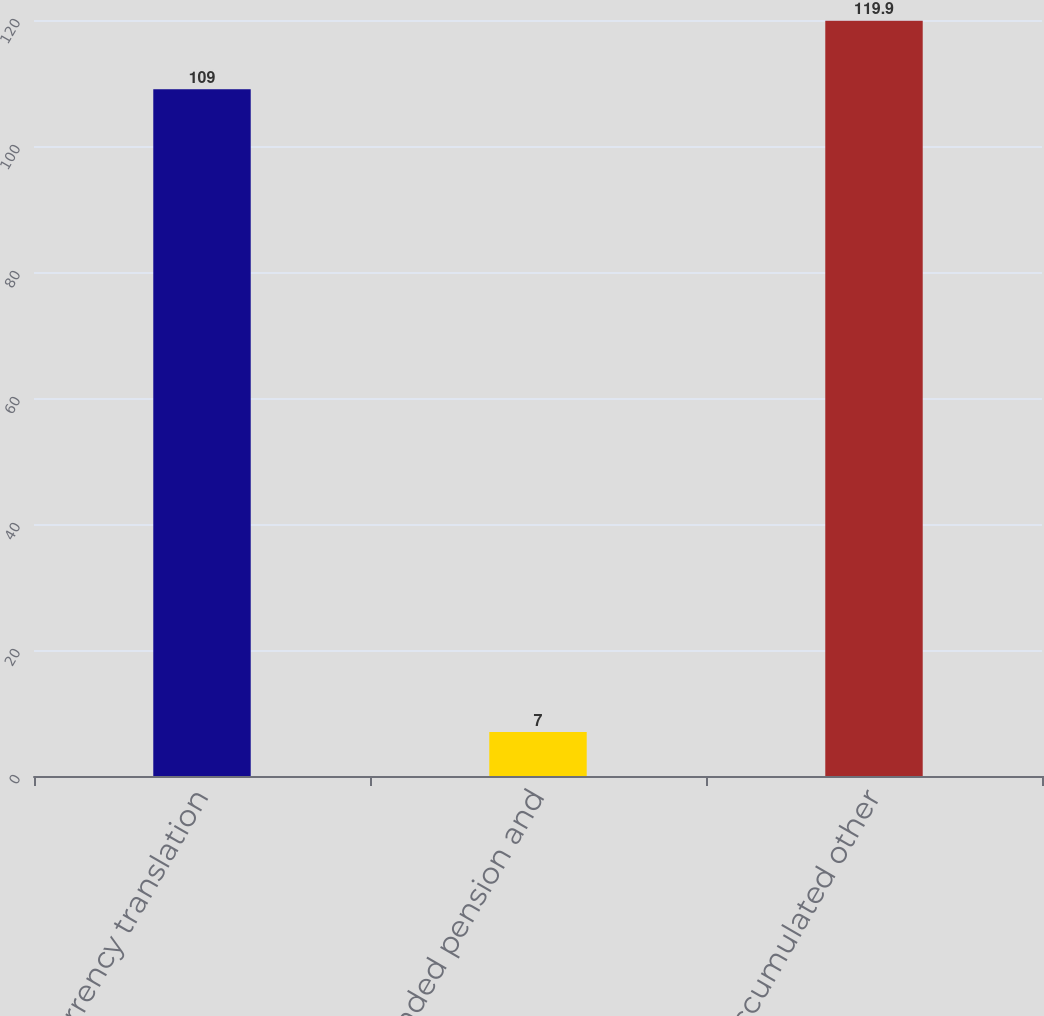<chart> <loc_0><loc_0><loc_500><loc_500><bar_chart><fcel>Currency translation<fcel>Unfunded pension and<fcel>Accumulated other<nl><fcel>109<fcel>7<fcel>119.9<nl></chart> 